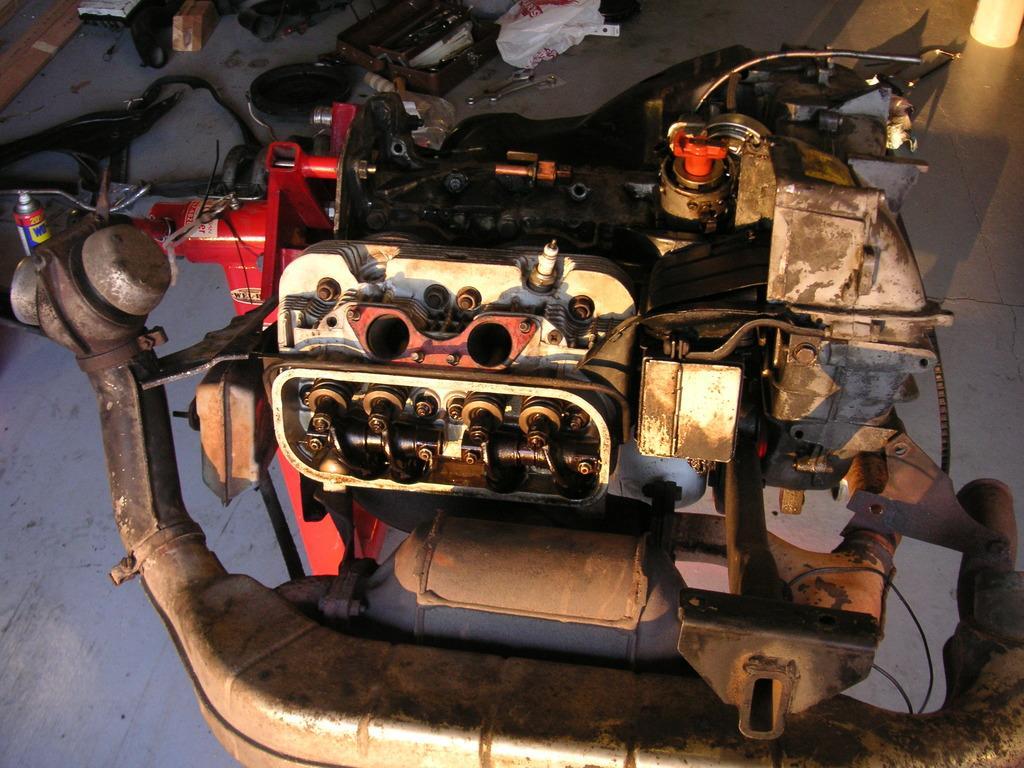Describe this image in one or two sentences. In the picture I can see machines and some other objects on the floor. 